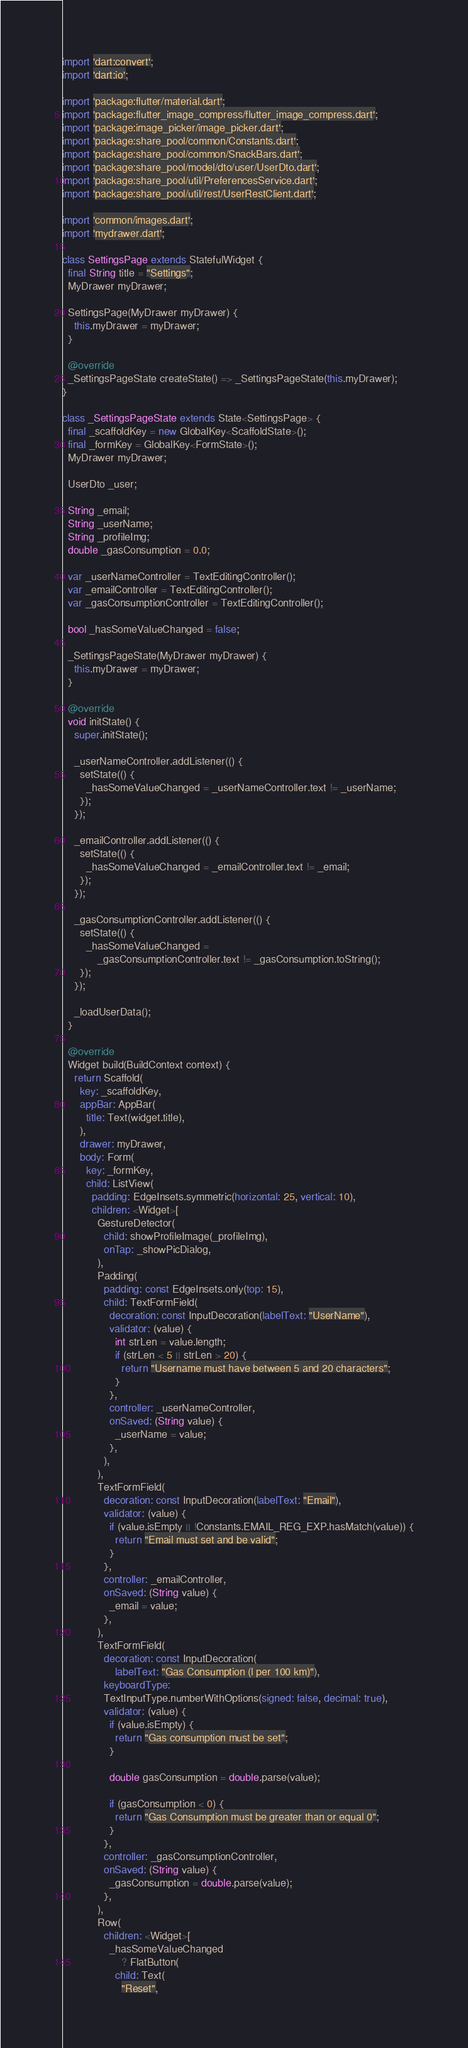<code> <loc_0><loc_0><loc_500><loc_500><_Dart_>import 'dart:convert';
import 'dart:io';

import 'package:flutter/material.dart';
import 'package:flutter_image_compress/flutter_image_compress.dart';
import 'package:image_picker/image_picker.dart';
import 'package:share_pool/common/Constants.dart';
import 'package:share_pool/common/SnackBars.dart';
import 'package:share_pool/model/dto/user/UserDto.dart';
import 'package:share_pool/util/PreferencesService.dart';
import 'package:share_pool/util/rest/UserRestClient.dart';

import 'common/images.dart';
import 'mydrawer.dart';

class SettingsPage extends StatefulWidget {
  final String title = "Settings";
  MyDrawer myDrawer;

  SettingsPage(MyDrawer myDrawer) {
    this.myDrawer = myDrawer;
  }

  @override
  _SettingsPageState createState() => _SettingsPageState(this.myDrawer);
}

class _SettingsPageState extends State<SettingsPage> {
  final _scaffoldKey = new GlobalKey<ScaffoldState>();
  final _formKey = GlobalKey<FormState>();
  MyDrawer myDrawer;

  UserDto _user;

  String _email;
  String _userName;
  String _profileImg;
  double _gasConsumption = 0.0;

  var _userNameController = TextEditingController();
  var _emailController = TextEditingController();
  var _gasConsumptionController = TextEditingController();

  bool _hasSomeValueChanged = false;

  _SettingsPageState(MyDrawer myDrawer) {
    this.myDrawer = myDrawer;
  }

  @override
  void initState() {
    super.initState();

    _userNameController.addListener(() {
      setState(() {
        _hasSomeValueChanged = _userNameController.text != _userName;
      });
    });

    _emailController.addListener(() {
      setState(() {
        _hasSomeValueChanged = _emailController.text != _email;
      });
    });

    _gasConsumptionController.addListener(() {
      setState(() {
        _hasSomeValueChanged =
            _gasConsumptionController.text != _gasConsumption.toString();
      });
    });

    _loadUserData();
  }

  @override
  Widget build(BuildContext context) {
    return Scaffold(
      key: _scaffoldKey,
      appBar: AppBar(
        title: Text(widget.title),
      ),
      drawer: myDrawer,
      body: Form(
        key: _formKey,
        child: ListView(
          padding: EdgeInsets.symmetric(horizontal: 25, vertical: 10),
          children: <Widget>[
            GestureDetector(
              child: showProfileImage(_profileImg),
              onTap: _showPicDialog,
            ),
            Padding(
              padding: const EdgeInsets.only(top: 15),
              child: TextFormField(
                decoration: const InputDecoration(labelText: "UserName"),
                validator: (value) {
                  int strLen = value.length;
                  if (strLen < 5 || strLen > 20) {
                    return "Username must have between 5 and 20 characters";
                  }
                },
                controller: _userNameController,
                onSaved: (String value) {
                  _userName = value;
                },
              ),
            ),
            TextFormField(
              decoration: const InputDecoration(labelText: "Email"),
              validator: (value) {
                if (value.isEmpty || !Constants.EMAIL_REG_EXP.hasMatch(value)) {
                  return "Email must set and be valid";
                }
              },
              controller: _emailController,
              onSaved: (String value) {
                _email = value;
              },
            ),
            TextFormField(
              decoration: const InputDecoration(
                  labelText: "Gas Consumption (l per 100 km)"),
              keyboardType:
              TextInputType.numberWithOptions(signed: false, decimal: true),
              validator: (value) {
                if (value.isEmpty) {
                  return "Gas consumption must be set";
                }

                double gasConsumption = double.parse(value);

                if (gasConsumption < 0) {
                  return "Gas Consumption must be greater than or equal 0";
                }
              },
              controller: _gasConsumptionController,
              onSaved: (String value) {
                _gasConsumption = double.parse(value);
              },
            ),
            Row(
              children: <Widget>[
                _hasSomeValueChanged
                    ? FlatButton(
                  child: Text(
                    "Reset",</code> 